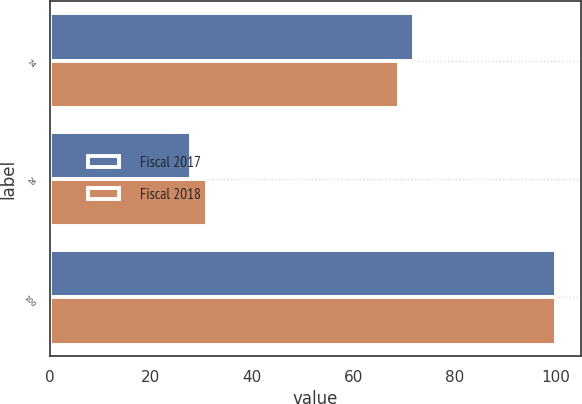Convert chart. <chart><loc_0><loc_0><loc_500><loc_500><stacked_bar_chart><ecel><fcel>74<fcel>26<fcel>100<nl><fcel>Fiscal 2017<fcel>72<fcel>28<fcel>100<nl><fcel>Fiscal 2018<fcel>69<fcel>31<fcel>100<nl></chart> 